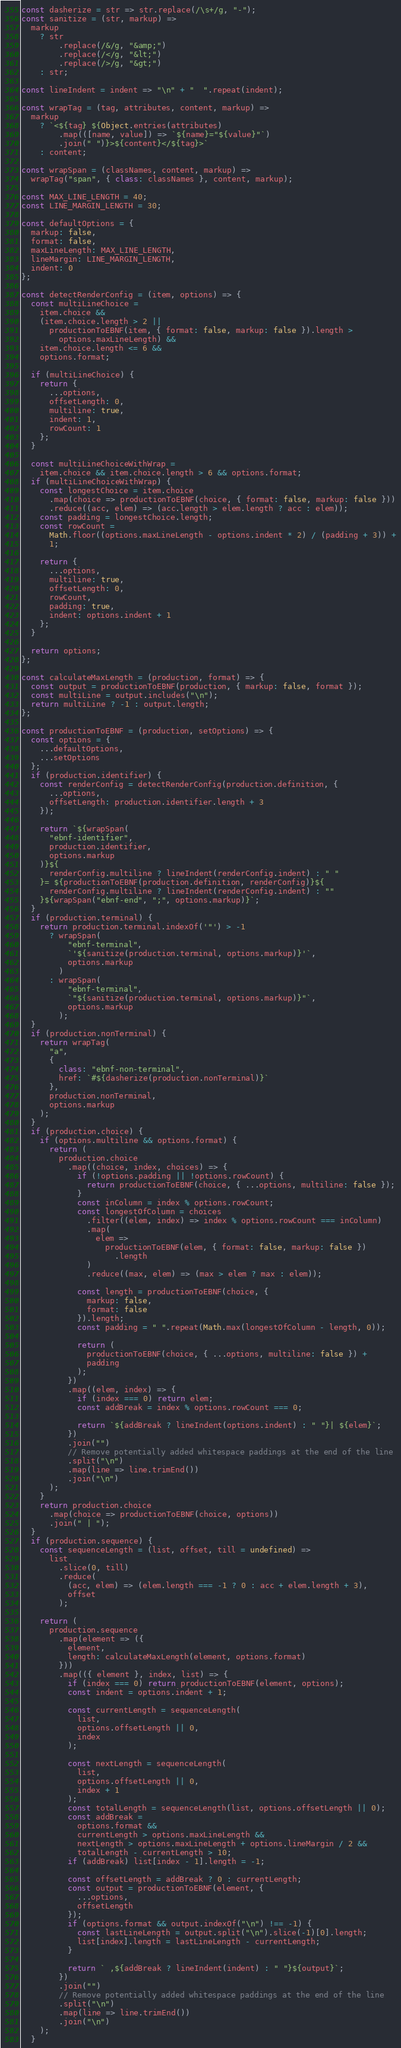<code> <loc_0><loc_0><loc_500><loc_500><_JavaScript_>const dasherize = str => str.replace(/\s+/g, "-");
const sanitize = (str, markup) =>
  markup
    ? str
        .replace(/&/g, "&amp;")
        .replace(/</g, "&lt;")
        .replace(/>/g, "&gt;")
    : str;

const lineIndent = indent => "\n" + "  ".repeat(indent);

const wrapTag = (tag, attributes, content, markup) =>
  markup
    ? `<${tag} ${Object.entries(attributes)
        .map(([name, value]) => `${name}="${value}"`)
        .join(" ")}>${content}</${tag}>`
    : content;

const wrapSpan = (classNames, content, markup) =>
  wrapTag("span", { class: classNames }, content, markup);

const MAX_LINE_LENGTH = 40;
const LINE_MARGIN_LENGTH = 30;

const defaultOptions = {
  markup: false,
  format: false,
  maxLineLength: MAX_LINE_LENGTH,
  lineMargin: LINE_MARGIN_LENGTH,
  indent: 0
};

const detectRenderConfig = (item, options) => {
  const multiLineChoice =
    item.choice &&
    (item.choice.length > 2 ||
      productionToEBNF(item, { format: false, markup: false }).length >
        options.maxLineLength) &&
    item.choice.length <= 6 &&
    options.format;

  if (multiLineChoice) {
    return {
      ...options,
      offsetLength: 0,
      multiline: true,
      indent: 1,
      rowCount: 1
    };
  }

  const multiLineChoiceWithWrap =
    item.choice && item.choice.length > 6 && options.format;
  if (multiLineChoiceWithWrap) {
    const longestChoice = item.choice
      .map(choice => productionToEBNF(choice, { format: false, markup: false }))
      .reduce((acc, elem) => (acc.length > elem.length ? acc : elem));
    const padding = longestChoice.length;
    const rowCount =
      Math.floor((options.maxLineLength - options.indent * 2) / (padding + 3)) +
      1;

    return {
      ...options,
      multiline: true,
      offsetLength: 0,
      rowCount,
      padding: true,
      indent: options.indent + 1
    };
  }

  return options;
};

const calculateMaxLength = (production, format) => {
  const output = productionToEBNF(production, { markup: false, format });
  const multiLine = output.includes("\n");
  return multiLine ? -1 : output.length;
};

const productionToEBNF = (production, setOptions) => {
  const options = {
    ...defaultOptions,
    ...setOptions
  };
  if (production.identifier) {
    const renderConfig = detectRenderConfig(production.definition, {
      ...options,
      offsetLength: production.identifier.length + 3
    });

    return `${wrapSpan(
      "ebnf-identifier",
      production.identifier,
      options.markup
    )}${
      renderConfig.multiline ? lineIndent(renderConfig.indent) : " "
    }= ${productionToEBNF(production.definition, renderConfig)}${
      renderConfig.multiline ? lineIndent(renderConfig.indent) : ""
    }${wrapSpan("ebnf-end", ";", options.markup)}`;
  }
  if (production.terminal) {
    return production.terminal.indexOf('"') > -1
      ? wrapSpan(
          "ebnf-terminal",
          `'${sanitize(production.terminal, options.markup)}'`,
          options.markup
        )
      : wrapSpan(
          "ebnf-terminal",
          `"${sanitize(production.terminal, options.markup)}"`,
          options.markup
        );
  }
  if (production.nonTerminal) {
    return wrapTag(
      "a",
      {
        class: "ebnf-non-terminal",
        href: `#${dasherize(production.nonTerminal)}`
      },
      production.nonTerminal,
      options.markup
    );
  }
  if (production.choice) {
    if (options.multiline && options.format) {
      return (
        production.choice
          .map((choice, index, choices) => {
            if (!options.padding || !options.rowCount) {
              return productionToEBNF(choice, { ...options, multiline: false });
            }
            const inColumn = index % options.rowCount;
            const longestOfColumn = choices
              .filter((elem, index) => index % options.rowCount === inColumn)
              .map(
                elem =>
                  productionToEBNF(elem, { format: false, markup: false })
                    .length
              )
              .reduce((max, elem) => (max > elem ? max : elem));

            const length = productionToEBNF(choice, {
              markup: false,
              format: false
            }).length;
            const padding = " ".repeat(Math.max(longestOfColumn - length, 0));

            return (
              productionToEBNF(choice, { ...options, multiline: false }) +
              padding
            );
          })
          .map((elem, index) => {
            if (index === 0) return elem;
            const addBreak = index % options.rowCount === 0;

            return `${addBreak ? lineIndent(options.indent) : " "}| ${elem}`;
          })
          .join("")
          // Remove potentially added whitespace paddings at the end of the line
          .split("\n")
          .map(line => line.trimEnd())
          .join("\n")
      );
    }
    return production.choice
      .map(choice => productionToEBNF(choice, options))
      .join(" | ");
  }
  if (production.sequence) {
    const sequenceLength = (list, offset, till = undefined) =>
      list
        .slice(0, till)
        .reduce(
          (acc, elem) => (elem.length === -1 ? 0 : acc + elem.length + 3),
          offset
        );

    return (
      production.sequence
        .map(element => ({
          element,
          length: calculateMaxLength(element, options.format)
        }))
        .map(({ element }, index, list) => {
          if (index === 0) return productionToEBNF(element, options);
          const indent = options.indent + 1;

          const currentLength = sequenceLength(
            list,
            options.offsetLength || 0,
            index
          );

          const nextLength = sequenceLength(
            list,
            options.offsetLength || 0,
            index + 1
          );
          const totalLength = sequenceLength(list, options.offsetLength || 0);
          const addBreak =
            options.format &&
            currentLength > options.maxLineLength &&
            nextLength > options.maxLineLength + options.lineMargin / 2 &&
            totalLength - currentLength > 10;
          if (addBreak) list[index - 1].length = -1;

          const offsetLength = addBreak ? 0 : currentLength;
          const output = productionToEBNF(element, {
            ...options,
            offsetLength
          });
          if (options.format && output.indexOf("\n") !== -1) {
            const lastLineLength = output.split("\n").slice(-1)[0].length;
            list[index].length = lastLineLength - currentLength;
          }

          return ` ,${addBreak ? lineIndent(indent) : " "}${output}`;
        })
        .join("")
        // Remove potentially added whitespace paddings at the end of the line
        .split("\n")
        .map(line => line.trimEnd())
        .join("\n")
    );
  }</code> 